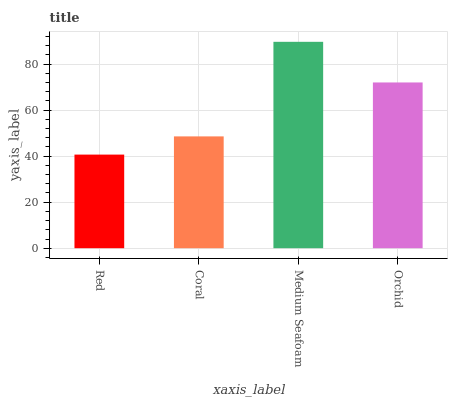Is Red the minimum?
Answer yes or no. Yes. Is Medium Seafoam the maximum?
Answer yes or no. Yes. Is Coral the minimum?
Answer yes or no. No. Is Coral the maximum?
Answer yes or no. No. Is Coral greater than Red?
Answer yes or no. Yes. Is Red less than Coral?
Answer yes or no. Yes. Is Red greater than Coral?
Answer yes or no. No. Is Coral less than Red?
Answer yes or no. No. Is Orchid the high median?
Answer yes or no. Yes. Is Coral the low median?
Answer yes or no. Yes. Is Red the high median?
Answer yes or no. No. Is Medium Seafoam the low median?
Answer yes or no. No. 